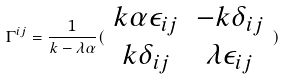Convert formula to latex. <formula><loc_0><loc_0><loc_500><loc_500>\Gamma ^ { i j } = \frac { 1 } { k - \lambda \alpha } ( \begin{array} { c c } k \alpha \epsilon _ { i j } & - k \delta _ { i j } \\ k \delta _ { i j } & \lambda \epsilon _ { i j } \end{array} )</formula> 